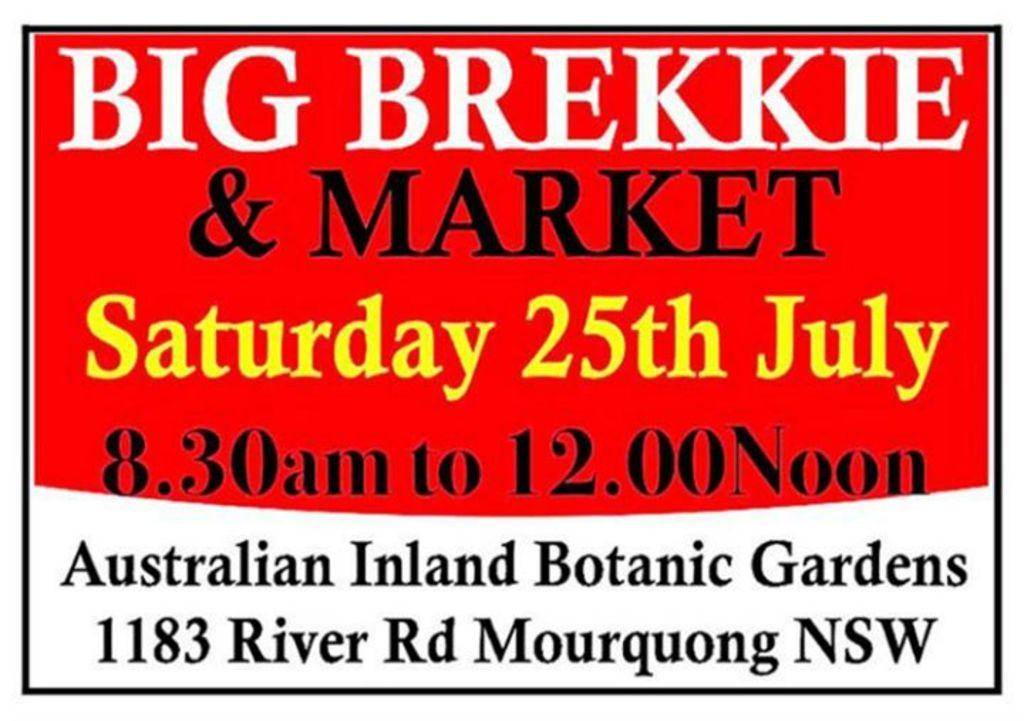<image>
Summarize the visual content of the image. A sign advertises an event for Saturday, the 25th of July. 